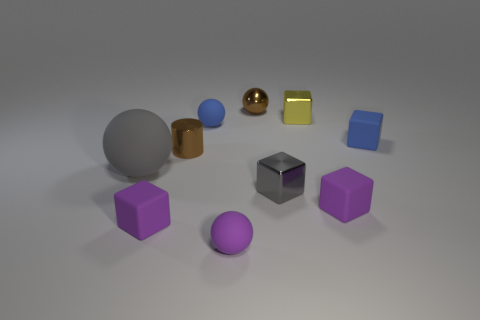The yellow metallic block has what size?
Provide a succinct answer. Small. Is the brown metal sphere the same size as the blue cube?
Your response must be concise. Yes. What number of objects are either blocks that are in front of the big rubber ball or tiny brown objects that are in front of the small yellow cube?
Ensure brevity in your answer.  4. What number of big gray balls are on the left side of the small purple matte thing to the right of the gray thing right of the blue sphere?
Your answer should be compact. 1. There is a blue object that is on the right side of the tiny yellow cube; what is its size?
Your answer should be compact. Small. What number of metallic blocks are the same size as the metal sphere?
Offer a terse response. 2. There is a brown metal ball; is it the same size as the blue rubber thing that is right of the tiny gray cube?
Make the answer very short. Yes. What number of things are either yellow metal cubes or large cyan metallic blocks?
Make the answer very short. 1. What number of small cylinders have the same color as the big ball?
Make the answer very short. 0. There is a yellow object that is the same size as the gray cube; what is its shape?
Your response must be concise. Cube. 